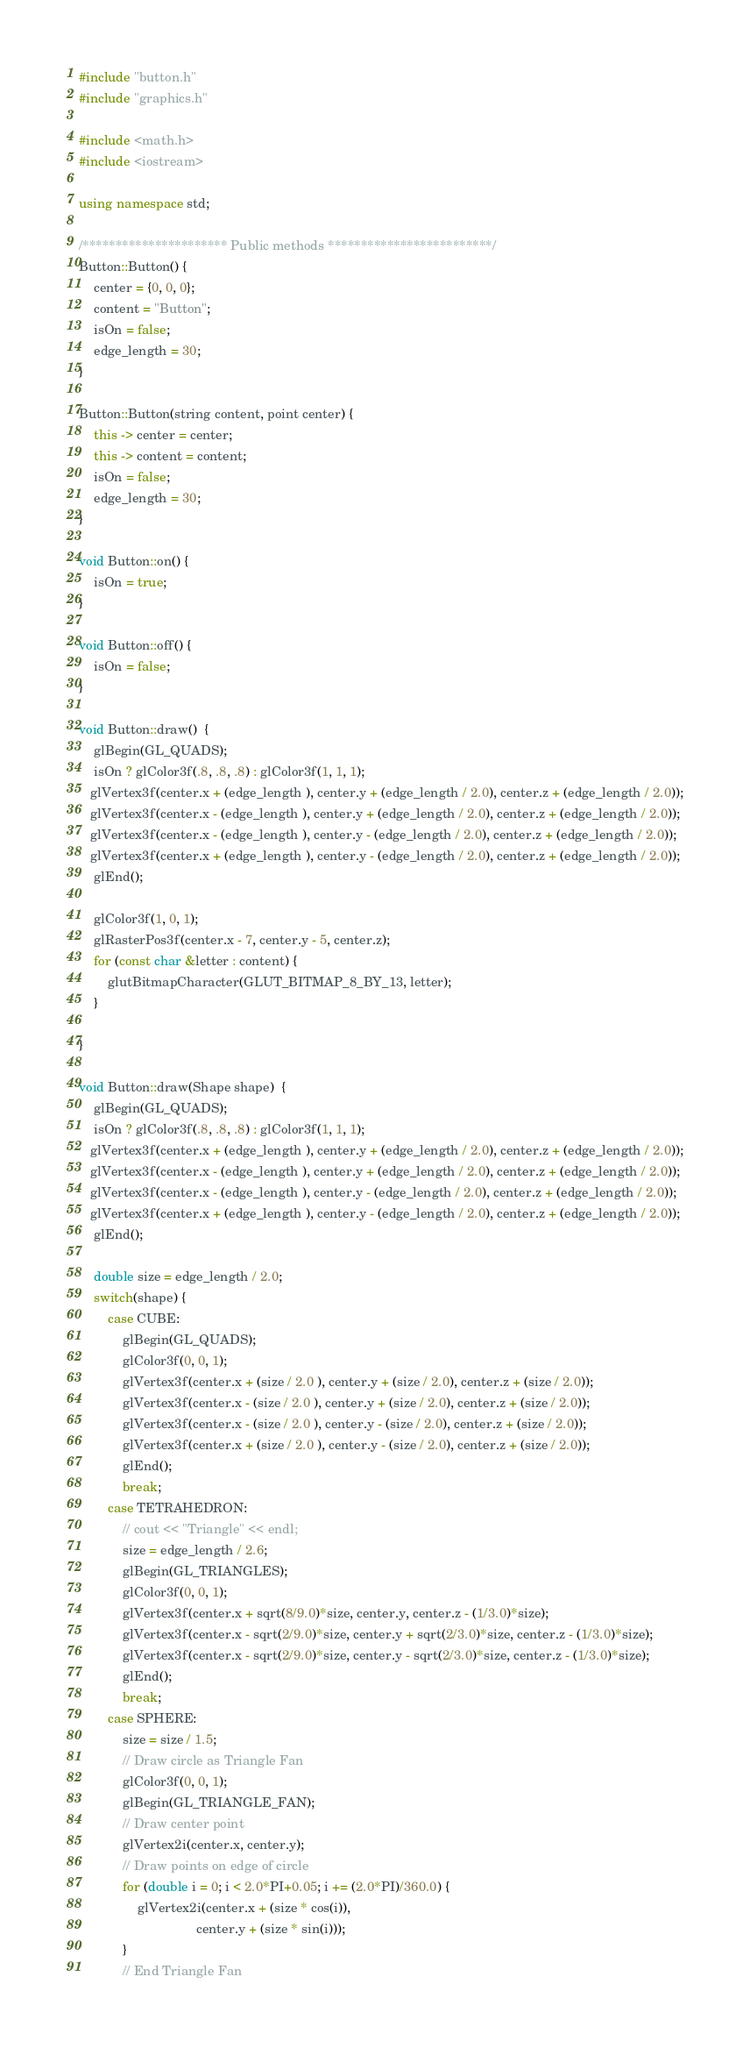<code> <loc_0><loc_0><loc_500><loc_500><_C++_>#include "button.h"
#include "graphics.h"

#include <math.h>
#include <iostream>

using namespace std;

/********************** Public methods *************************/
Button::Button() {
	center = {0, 0, 0};
	content = "Button";
	isOn = false;
	edge_length = 30;
}

Button::Button(string content, point center) {
	this -> center = center;
	this -> content = content;
	isOn = false;
	edge_length = 30;
}

void Button::on() {
	isOn = true;
}

void Button::off() {
	isOn = false;
}

void Button::draw()  {
	glBegin(GL_QUADS);
	isOn ? glColor3f(.8, .8, .8) : glColor3f(1, 1, 1);
   glVertex3f(center.x + (edge_length ), center.y + (edge_length / 2.0), center.z + (edge_length / 2.0));
   glVertex3f(center.x - (edge_length ), center.y + (edge_length / 2.0), center.z + (edge_length / 2.0));
   glVertex3f(center.x - (edge_length ), center.y - (edge_length / 2.0), center.z + (edge_length / 2.0));
   glVertex3f(center.x + (edge_length ), center.y - (edge_length / 2.0), center.z + (edge_length / 2.0));
	glEnd();

	glColor3f(1, 0, 1);
	glRasterPos3f(center.x - 7, center.y - 5, center.z);
	for (const char &letter : content) {
		glutBitmapCharacter(GLUT_BITMAP_8_BY_13, letter);
	}

}

void Button::draw(Shape shape)  {
	glBegin(GL_QUADS);
	isOn ? glColor3f(.8, .8, .8) : glColor3f(1, 1, 1);
   glVertex3f(center.x + (edge_length ), center.y + (edge_length / 2.0), center.z + (edge_length / 2.0));
   glVertex3f(center.x - (edge_length ), center.y + (edge_length / 2.0), center.z + (edge_length / 2.0));
   glVertex3f(center.x - (edge_length ), center.y - (edge_length / 2.0), center.z + (edge_length / 2.0));
   glVertex3f(center.x + (edge_length ), center.y - (edge_length / 2.0), center.z + (edge_length / 2.0));
	glEnd();

	double size = edge_length / 2.0;
	switch(shape) {
		case CUBE: 
			glBegin(GL_QUADS);
			glColor3f(0, 0, 1);
			glVertex3f(center.x + (size / 2.0 ), center.y + (size / 2.0), center.z + (size / 2.0));
			glVertex3f(center.x - (size / 2.0 ), center.y + (size / 2.0), center.z + (size / 2.0));
			glVertex3f(center.x - (size / 2.0 ), center.y - (size / 2.0), center.z + (size / 2.0));
			glVertex3f(center.x + (size / 2.0 ), center.y - (size / 2.0), center.z + (size / 2.0));
			glEnd();
			break;
		case TETRAHEDRON: 
			// cout << "Triangle" << endl;
			size = edge_length / 2.6;
			glBegin(GL_TRIANGLES);
			glColor3f(0, 0, 1);
			glVertex3f(center.x + sqrt(8/9.0)*size, center.y, center.z - (1/3.0)*size);
			glVertex3f(center.x - sqrt(2/9.0)*size, center.y + sqrt(2/3.0)*size, center.z - (1/3.0)*size);
			glVertex3f(center.x - sqrt(2/9.0)*size, center.y - sqrt(2/3.0)*size, center.z - (1/3.0)*size);
			glEnd();
			break;
		case SPHERE: 
			size = size / 1.5;
			// Draw circle as Triangle Fan
			glColor3f(0, 0, 1);
			glBegin(GL_TRIANGLE_FAN);
			// Draw center point
			glVertex2i(center.x, center.y);
			// Draw points on edge of circle
			for (double i = 0; i < 2.0*PI+0.05; i += (2.0*PI)/360.0) {
				glVertex2i(center.x + (size * cos(i)),
								center.y + (size * sin(i)));
			}
			// End Triangle Fan</code> 